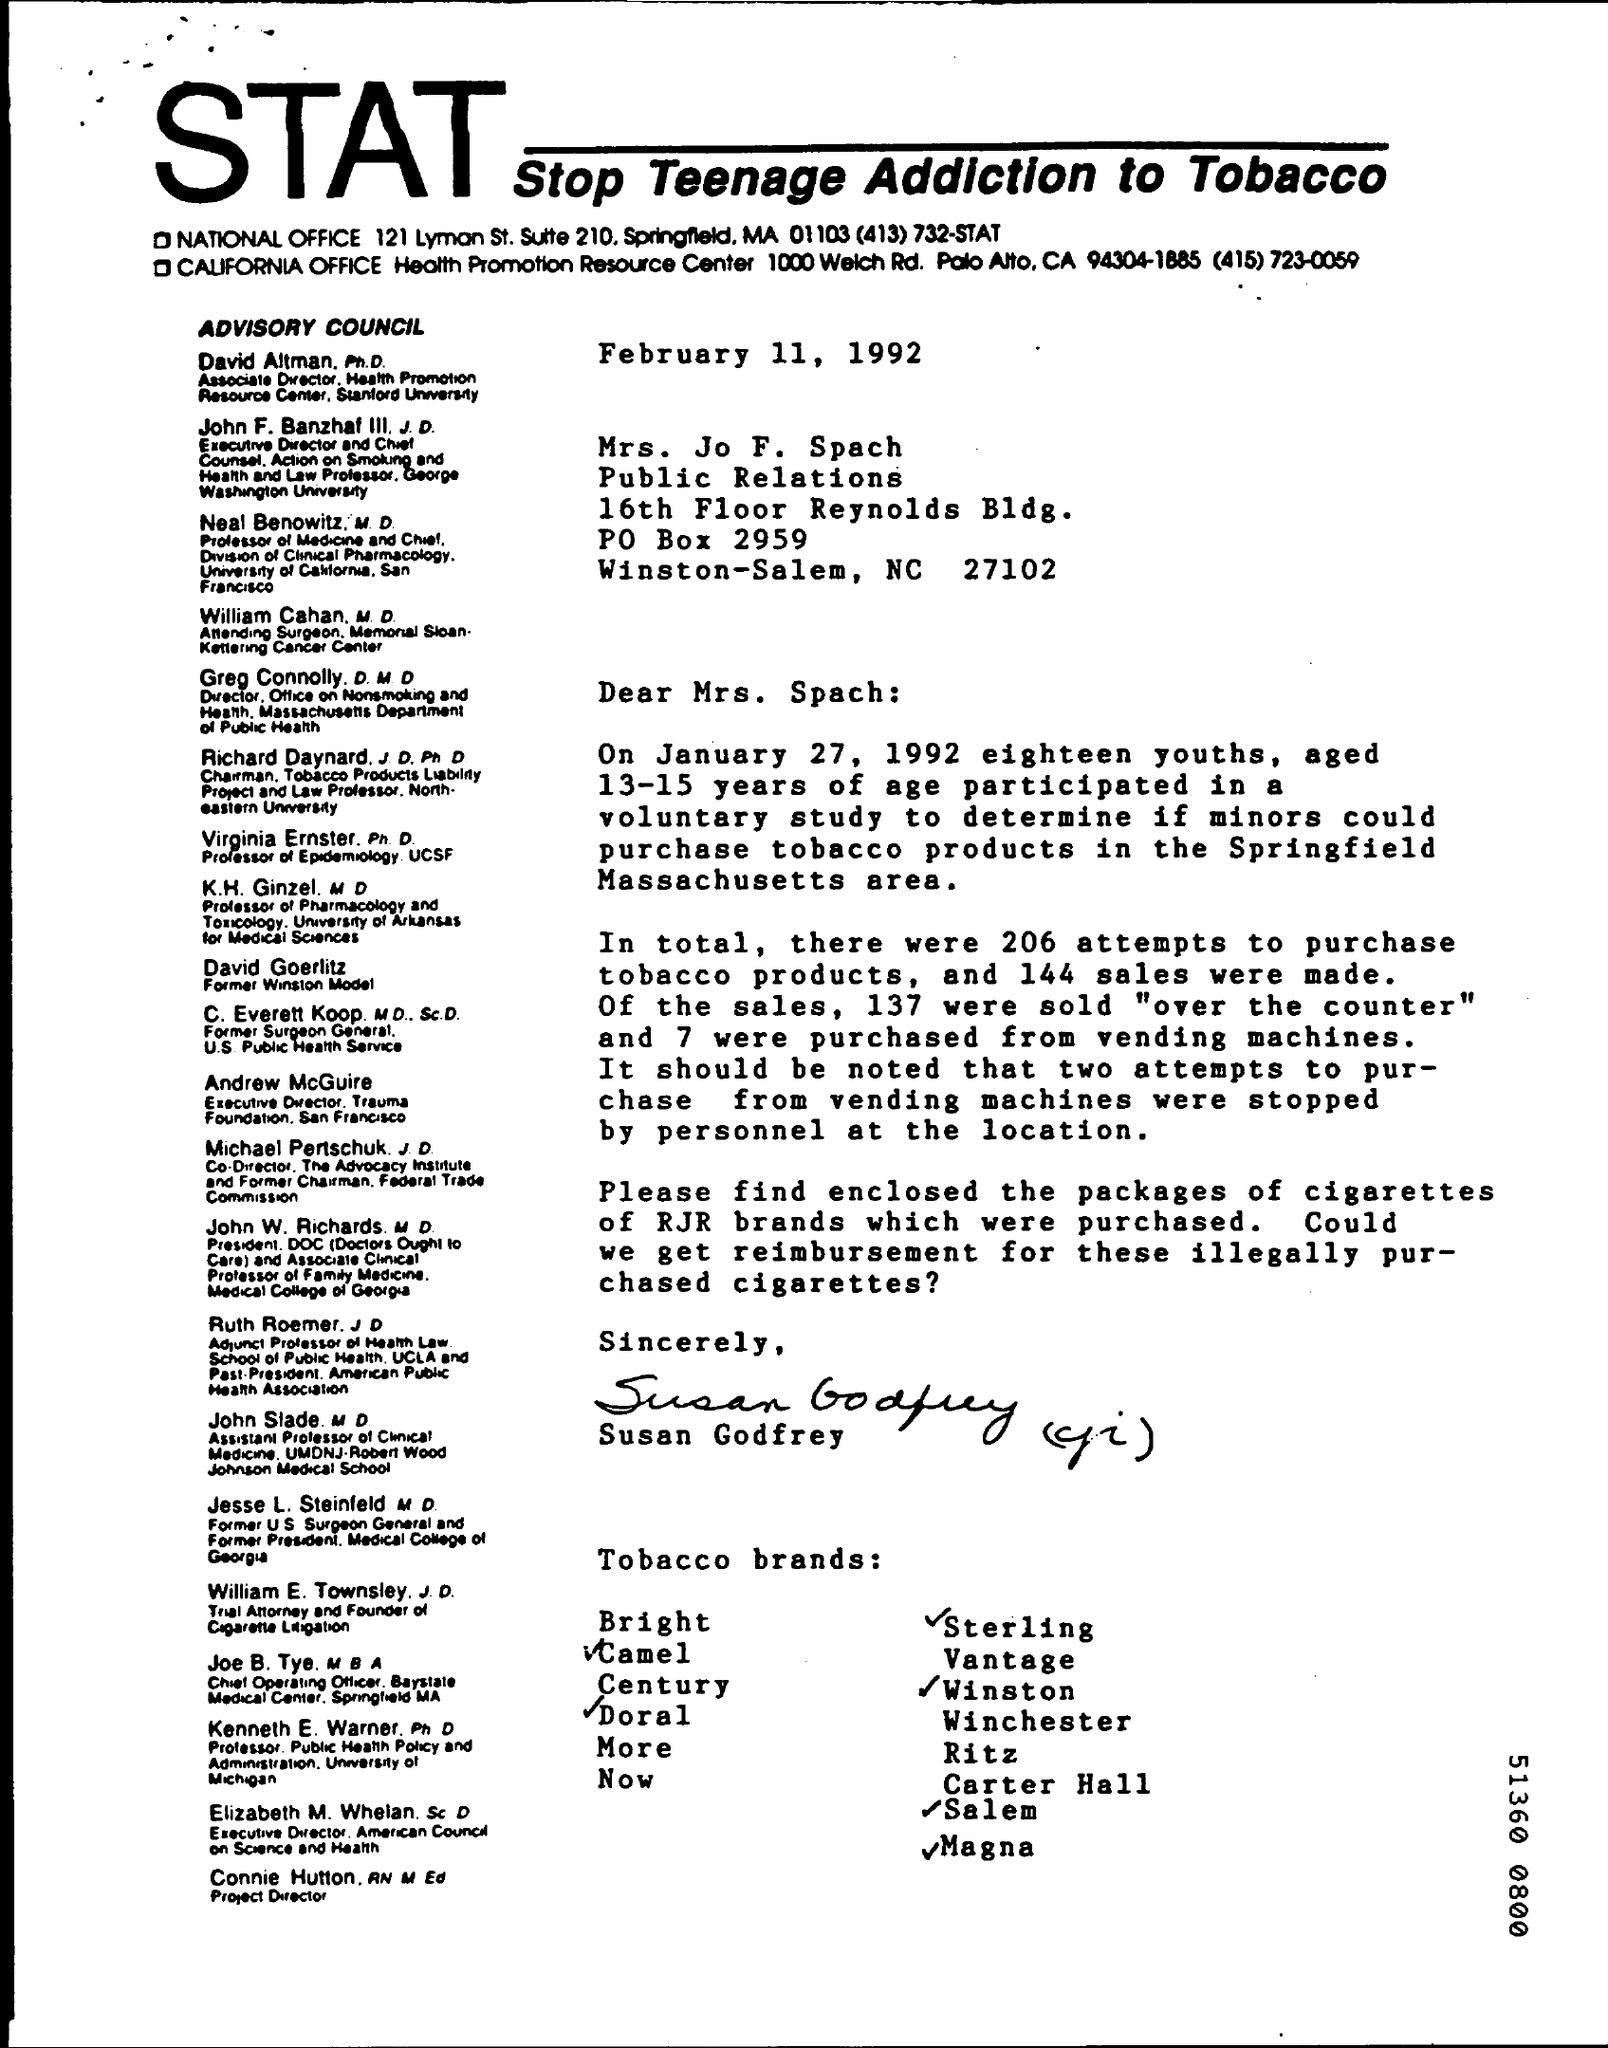What does STAT stand for?
Your response must be concise. Stop Teenage Addiction to Tobacco. When is the letter dated?
Your response must be concise. February 11, 1992. To whom is the letter addressed?
Provide a short and direct response. Mrs. Jo F. Spach. 